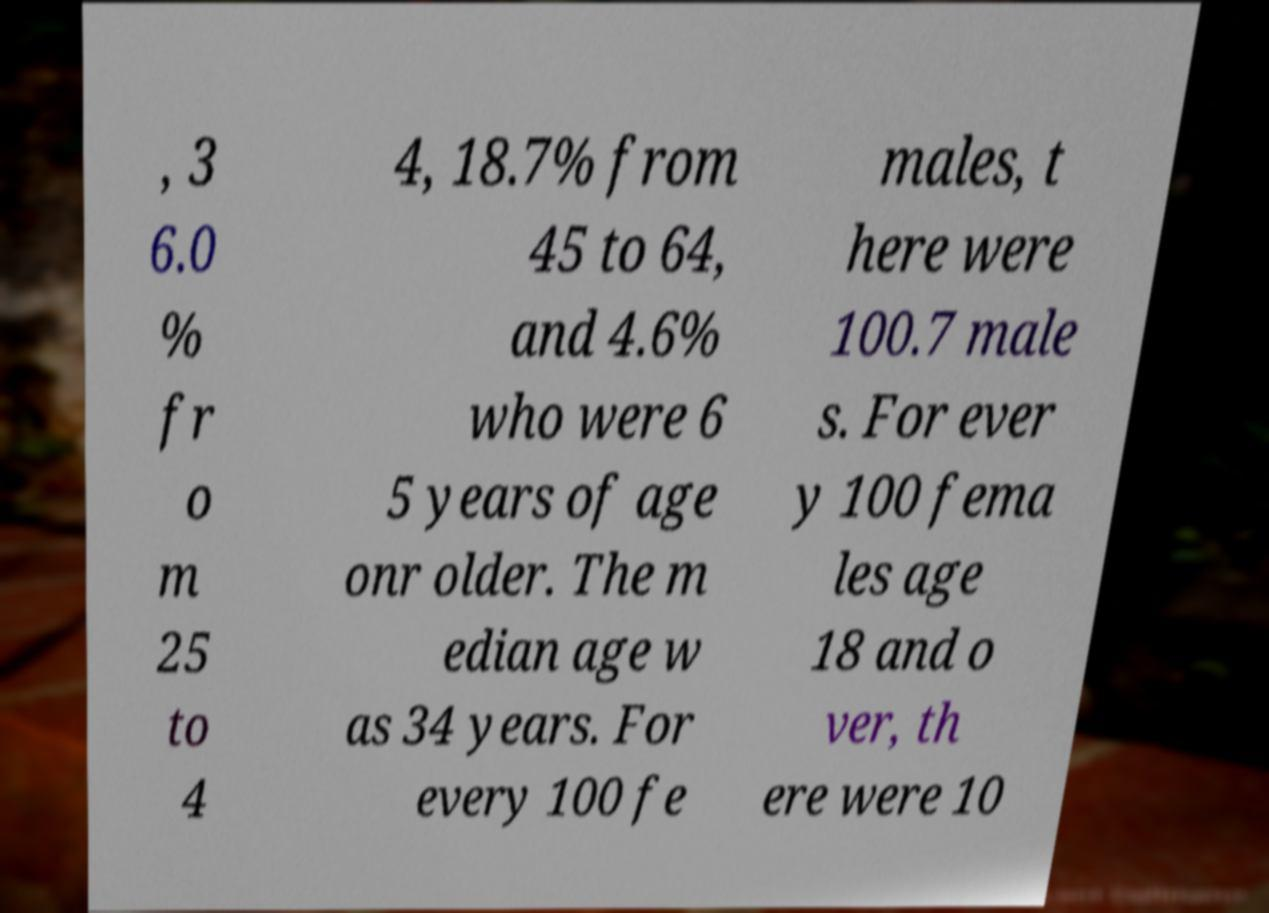For documentation purposes, I need the text within this image transcribed. Could you provide that? , 3 6.0 % fr o m 25 to 4 4, 18.7% from 45 to 64, and 4.6% who were 6 5 years of age onr older. The m edian age w as 34 years. For every 100 fe males, t here were 100.7 male s. For ever y 100 fema les age 18 and o ver, th ere were 10 